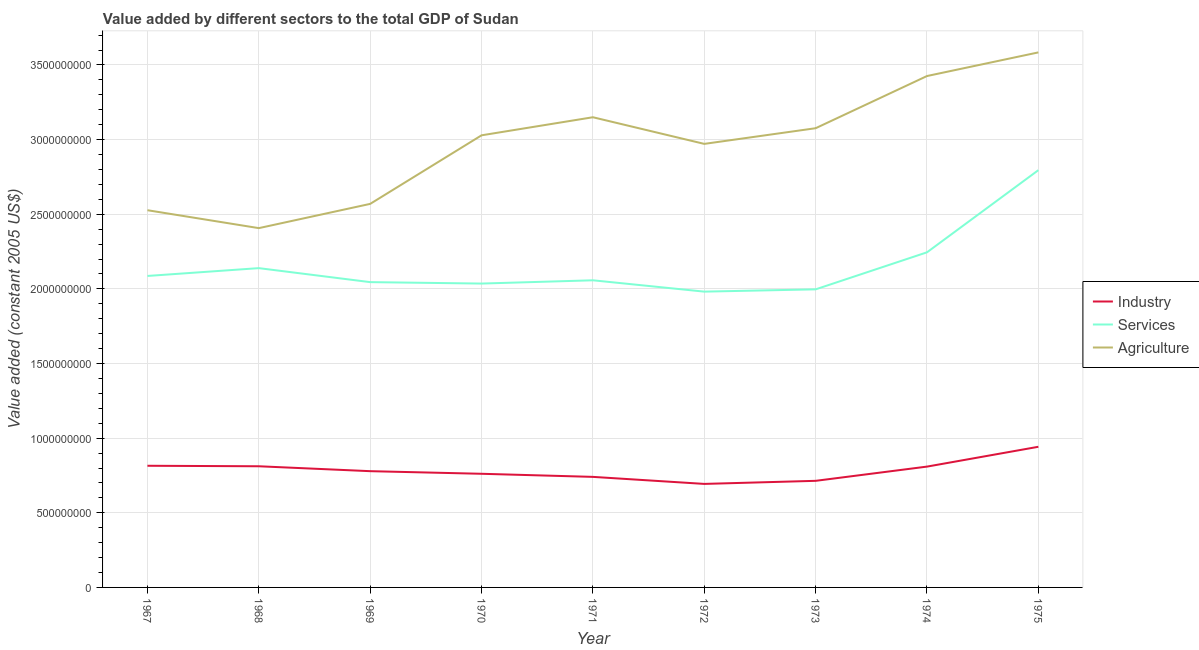How many different coloured lines are there?
Make the answer very short. 3. Does the line corresponding to value added by agricultural sector intersect with the line corresponding to value added by industrial sector?
Offer a very short reply. No. Is the number of lines equal to the number of legend labels?
Your response must be concise. Yes. What is the value added by services in 1967?
Your answer should be very brief. 2.09e+09. Across all years, what is the maximum value added by services?
Your answer should be compact. 2.80e+09. Across all years, what is the minimum value added by industrial sector?
Offer a very short reply. 6.93e+08. In which year was the value added by industrial sector maximum?
Offer a very short reply. 1975. What is the total value added by industrial sector in the graph?
Keep it short and to the point. 7.07e+09. What is the difference between the value added by industrial sector in 1972 and that in 1973?
Keep it short and to the point. -2.06e+07. What is the difference between the value added by industrial sector in 1971 and the value added by services in 1973?
Give a very brief answer. -1.26e+09. What is the average value added by services per year?
Your response must be concise. 2.15e+09. In the year 1969, what is the difference between the value added by agricultural sector and value added by industrial sector?
Provide a short and direct response. 1.79e+09. In how many years, is the value added by agricultural sector greater than 2300000000 US$?
Offer a terse response. 9. What is the ratio of the value added by industrial sector in 1970 to that in 1975?
Give a very brief answer. 0.81. Is the value added by agricultural sector in 1972 less than that in 1974?
Provide a short and direct response. Yes. What is the difference between the highest and the second highest value added by services?
Your response must be concise. 5.50e+08. What is the difference between the highest and the lowest value added by industrial sector?
Offer a very short reply. 2.49e+08. Does the value added by services monotonically increase over the years?
Offer a terse response. No. Is the value added by agricultural sector strictly greater than the value added by industrial sector over the years?
Keep it short and to the point. Yes. Is the value added by industrial sector strictly less than the value added by agricultural sector over the years?
Offer a very short reply. Yes. Does the graph contain grids?
Ensure brevity in your answer.  Yes. How many legend labels are there?
Your answer should be very brief. 3. How are the legend labels stacked?
Make the answer very short. Vertical. What is the title of the graph?
Provide a short and direct response. Value added by different sectors to the total GDP of Sudan. Does "Gaseous fuel" appear as one of the legend labels in the graph?
Make the answer very short. No. What is the label or title of the Y-axis?
Your response must be concise. Value added (constant 2005 US$). What is the Value added (constant 2005 US$) in Industry in 1967?
Offer a terse response. 8.15e+08. What is the Value added (constant 2005 US$) in Services in 1967?
Offer a very short reply. 2.09e+09. What is the Value added (constant 2005 US$) in Agriculture in 1967?
Your response must be concise. 2.53e+09. What is the Value added (constant 2005 US$) in Industry in 1968?
Provide a short and direct response. 8.12e+08. What is the Value added (constant 2005 US$) in Services in 1968?
Keep it short and to the point. 2.14e+09. What is the Value added (constant 2005 US$) in Agriculture in 1968?
Offer a very short reply. 2.41e+09. What is the Value added (constant 2005 US$) in Industry in 1969?
Offer a very short reply. 7.79e+08. What is the Value added (constant 2005 US$) in Services in 1969?
Your response must be concise. 2.05e+09. What is the Value added (constant 2005 US$) of Agriculture in 1969?
Your response must be concise. 2.57e+09. What is the Value added (constant 2005 US$) of Industry in 1970?
Offer a terse response. 7.61e+08. What is the Value added (constant 2005 US$) of Services in 1970?
Provide a short and direct response. 2.04e+09. What is the Value added (constant 2005 US$) in Agriculture in 1970?
Offer a terse response. 3.03e+09. What is the Value added (constant 2005 US$) in Industry in 1971?
Offer a very short reply. 7.41e+08. What is the Value added (constant 2005 US$) in Services in 1971?
Give a very brief answer. 2.06e+09. What is the Value added (constant 2005 US$) of Agriculture in 1971?
Your answer should be very brief. 3.15e+09. What is the Value added (constant 2005 US$) in Industry in 1972?
Your answer should be very brief. 6.93e+08. What is the Value added (constant 2005 US$) in Services in 1972?
Offer a very short reply. 1.98e+09. What is the Value added (constant 2005 US$) in Agriculture in 1972?
Your response must be concise. 2.97e+09. What is the Value added (constant 2005 US$) in Industry in 1973?
Keep it short and to the point. 7.14e+08. What is the Value added (constant 2005 US$) in Services in 1973?
Offer a very short reply. 2.00e+09. What is the Value added (constant 2005 US$) in Agriculture in 1973?
Offer a very short reply. 3.08e+09. What is the Value added (constant 2005 US$) in Industry in 1974?
Give a very brief answer. 8.09e+08. What is the Value added (constant 2005 US$) in Services in 1974?
Your answer should be very brief. 2.24e+09. What is the Value added (constant 2005 US$) of Agriculture in 1974?
Your response must be concise. 3.43e+09. What is the Value added (constant 2005 US$) in Industry in 1975?
Ensure brevity in your answer.  9.42e+08. What is the Value added (constant 2005 US$) of Services in 1975?
Keep it short and to the point. 2.80e+09. What is the Value added (constant 2005 US$) in Agriculture in 1975?
Provide a short and direct response. 3.58e+09. Across all years, what is the maximum Value added (constant 2005 US$) of Industry?
Your response must be concise. 9.42e+08. Across all years, what is the maximum Value added (constant 2005 US$) of Services?
Keep it short and to the point. 2.80e+09. Across all years, what is the maximum Value added (constant 2005 US$) in Agriculture?
Offer a terse response. 3.58e+09. Across all years, what is the minimum Value added (constant 2005 US$) in Industry?
Provide a succinct answer. 6.93e+08. Across all years, what is the minimum Value added (constant 2005 US$) in Services?
Provide a short and direct response. 1.98e+09. Across all years, what is the minimum Value added (constant 2005 US$) in Agriculture?
Make the answer very short. 2.41e+09. What is the total Value added (constant 2005 US$) of Industry in the graph?
Provide a succinct answer. 7.07e+09. What is the total Value added (constant 2005 US$) in Services in the graph?
Ensure brevity in your answer.  1.94e+1. What is the total Value added (constant 2005 US$) in Agriculture in the graph?
Offer a very short reply. 2.67e+1. What is the difference between the Value added (constant 2005 US$) of Industry in 1967 and that in 1968?
Offer a terse response. 3.33e+06. What is the difference between the Value added (constant 2005 US$) in Services in 1967 and that in 1968?
Provide a succinct answer. -5.24e+07. What is the difference between the Value added (constant 2005 US$) in Agriculture in 1967 and that in 1968?
Make the answer very short. 1.20e+08. What is the difference between the Value added (constant 2005 US$) in Industry in 1967 and that in 1969?
Your answer should be very brief. 3.62e+07. What is the difference between the Value added (constant 2005 US$) in Services in 1967 and that in 1969?
Your answer should be very brief. 4.14e+07. What is the difference between the Value added (constant 2005 US$) of Agriculture in 1967 and that in 1969?
Make the answer very short. -4.23e+07. What is the difference between the Value added (constant 2005 US$) in Industry in 1967 and that in 1970?
Your answer should be very brief. 5.36e+07. What is the difference between the Value added (constant 2005 US$) of Services in 1967 and that in 1970?
Your answer should be very brief. 5.10e+07. What is the difference between the Value added (constant 2005 US$) in Agriculture in 1967 and that in 1970?
Your answer should be very brief. -5.02e+08. What is the difference between the Value added (constant 2005 US$) of Industry in 1967 and that in 1971?
Your answer should be compact. 7.44e+07. What is the difference between the Value added (constant 2005 US$) of Services in 1967 and that in 1971?
Your answer should be very brief. 2.91e+07. What is the difference between the Value added (constant 2005 US$) of Agriculture in 1967 and that in 1971?
Your answer should be compact. -6.23e+08. What is the difference between the Value added (constant 2005 US$) in Industry in 1967 and that in 1972?
Ensure brevity in your answer.  1.22e+08. What is the difference between the Value added (constant 2005 US$) in Services in 1967 and that in 1972?
Your answer should be very brief. 1.05e+08. What is the difference between the Value added (constant 2005 US$) in Agriculture in 1967 and that in 1972?
Ensure brevity in your answer.  -4.44e+08. What is the difference between the Value added (constant 2005 US$) in Industry in 1967 and that in 1973?
Offer a very short reply. 1.01e+08. What is the difference between the Value added (constant 2005 US$) in Services in 1967 and that in 1973?
Keep it short and to the point. 8.98e+07. What is the difference between the Value added (constant 2005 US$) in Agriculture in 1967 and that in 1973?
Ensure brevity in your answer.  -5.49e+08. What is the difference between the Value added (constant 2005 US$) of Industry in 1967 and that in 1974?
Make the answer very short. 5.62e+06. What is the difference between the Value added (constant 2005 US$) of Services in 1967 and that in 1974?
Keep it short and to the point. -1.58e+08. What is the difference between the Value added (constant 2005 US$) of Agriculture in 1967 and that in 1974?
Offer a terse response. -8.99e+08. What is the difference between the Value added (constant 2005 US$) in Industry in 1967 and that in 1975?
Your answer should be very brief. -1.27e+08. What is the difference between the Value added (constant 2005 US$) in Services in 1967 and that in 1975?
Provide a short and direct response. -7.09e+08. What is the difference between the Value added (constant 2005 US$) of Agriculture in 1967 and that in 1975?
Your response must be concise. -1.06e+09. What is the difference between the Value added (constant 2005 US$) in Industry in 1968 and that in 1969?
Offer a very short reply. 3.29e+07. What is the difference between the Value added (constant 2005 US$) in Services in 1968 and that in 1969?
Offer a very short reply. 9.37e+07. What is the difference between the Value added (constant 2005 US$) in Agriculture in 1968 and that in 1969?
Give a very brief answer. -1.62e+08. What is the difference between the Value added (constant 2005 US$) in Industry in 1968 and that in 1970?
Ensure brevity in your answer.  5.03e+07. What is the difference between the Value added (constant 2005 US$) of Services in 1968 and that in 1970?
Offer a very short reply. 1.03e+08. What is the difference between the Value added (constant 2005 US$) of Agriculture in 1968 and that in 1970?
Your response must be concise. -6.22e+08. What is the difference between the Value added (constant 2005 US$) in Industry in 1968 and that in 1971?
Your answer should be very brief. 7.11e+07. What is the difference between the Value added (constant 2005 US$) in Services in 1968 and that in 1971?
Provide a succinct answer. 8.15e+07. What is the difference between the Value added (constant 2005 US$) in Agriculture in 1968 and that in 1971?
Ensure brevity in your answer.  -7.43e+08. What is the difference between the Value added (constant 2005 US$) of Industry in 1968 and that in 1972?
Give a very brief answer. 1.18e+08. What is the difference between the Value added (constant 2005 US$) in Services in 1968 and that in 1972?
Provide a short and direct response. 1.57e+08. What is the difference between the Value added (constant 2005 US$) in Agriculture in 1968 and that in 1972?
Make the answer very short. -5.64e+08. What is the difference between the Value added (constant 2005 US$) in Industry in 1968 and that in 1973?
Provide a short and direct response. 9.76e+07. What is the difference between the Value added (constant 2005 US$) of Services in 1968 and that in 1973?
Your response must be concise. 1.42e+08. What is the difference between the Value added (constant 2005 US$) in Agriculture in 1968 and that in 1973?
Provide a succinct answer. -6.69e+08. What is the difference between the Value added (constant 2005 US$) of Industry in 1968 and that in 1974?
Provide a short and direct response. 2.29e+06. What is the difference between the Value added (constant 2005 US$) of Services in 1968 and that in 1974?
Offer a very short reply. -1.06e+08. What is the difference between the Value added (constant 2005 US$) of Agriculture in 1968 and that in 1974?
Make the answer very short. -1.02e+09. What is the difference between the Value added (constant 2005 US$) in Industry in 1968 and that in 1975?
Keep it short and to the point. -1.31e+08. What is the difference between the Value added (constant 2005 US$) in Services in 1968 and that in 1975?
Your response must be concise. -6.56e+08. What is the difference between the Value added (constant 2005 US$) in Agriculture in 1968 and that in 1975?
Your response must be concise. -1.18e+09. What is the difference between the Value added (constant 2005 US$) in Industry in 1969 and that in 1970?
Your answer should be very brief. 1.74e+07. What is the difference between the Value added (constant 2005 US$) of Services in 1969 and that in 1970?
Your response must be concise. 9.57e+06. What is the difference between the Value added (constant 2005 US$) of Agriculture in 1969 and that in 1970?
Your answer should be compact. -4.59e+08. What is the difference between the Value added (constant 2005 US$) of Industry in 1969 and that in 1971?
Your answer should be compact. 3.82e+07. What is the difference between the Value added (constant 2005 US$) of Services in 1969 and that in 1971?
Offer a very short reply. -1.23e+07. What is the difference between the Value added (constant 2005 US$) in Agriculture in 1969 and that in 1971?
Keep it short and to the point. -5.80e+08. What is the difference between the Value added (constant 2005 US$) of Industry in 1969 and that in 1972?
Offer a terse response. 8.53e+07. What is the difference between the Value added (constant 2005 US$) in Services in 1969 and that in 1972?
Your answer should be very brief. 6.36e+07. What is the difference between the Value added (constant 2005 US$) of Agriculture in 1969 and that in 1972?
Keep it short and to the point. -4.02e+08. What is the difference between the Value added (constant 2005 US$) of Industry in 1969 and that in 1973?
Make the answer very short. 6.47e+07. What is the difference between the Value added (constant 2005 US$) in Services in 1969 and that in 1973?
Give a very brief answer. 4.84e+07. What is the difference between the Value added (constant 2005 US$) in Agriculture in 1969 and that in 1973?
Make the answer very short. -5.07e+08. What is the difference between the Value added (constant 2005 US$) in Industry in 1969 and that in 1974?
Your response must be concise. -3.06e+07. What is the difference between the Value added (constant 2005 US$) in Services in 1969 and that in 1974?
Offer a very short reply. -2.00e+08. What is the difference between the Value added (constant 2005 US$) of Agriculture in 1969 and that in 1974?
Make the answer very short. -8.56e+08. What is the difference between the Value added (constant 2005 US$) in Industry in 1969 and that in 1975?
Ensure brevity in your answer.  -1.63e+08. What is the difference between the Value added (constant 2005 US$) of Services in 1969 and that in 1975?
Your answer should be compact. -7.50e+08. What is the difference between the Value added (constant 2005 US$) of Agriculture in 1969 and that in 1975?
Keep it short and to the point. -1.01e+09. What is the difference between the Value added (constant 2005 US$) of Industry in 1970 and that in 1971?
Keep it short and to the point. 2.08e+07. What is the difference between the Value added (constant 2005 US$) of Services in 1970 and that in 1971?
Your answer should be very brief. -2.19e+07. What is the difference between the Value added (constant 2005 US$) of Agriculture in 1970 and that in 1971?
Offer a very short reply. -1.21e+08. What is the difference between the Value added (constant 2005 US$) in Industry in 1970 and that in 1972?
Provide a succinct answer. 6.79e+07. What is the difference between the Value added (constant 2005 US$) in Services in 1970 and that in 1972?
Make the answer very short. 5.41e+07. What is the difference between the Value added (constant 2005 US$) in Agriculture in 1970 and that in 1972?
Offer a terse response. 5.74e+07. What is the difference between the Value added (constant 2005 US$) of Industry in 1970 and that in 1973?
Ensure brevity in your answer.  4.73e+07. What is the difference between the Value added (constant 2005 US$) in Services in 1970 and that in 1973?
Provide a short and direct response. 3.88e+07. What is the difference between the Value added (constant 2005 US$) in Agriculture in 1970 and that in 1973?
Keep it short and to the point. -4.75e+07. What is the difference between the Value added (constant 2005 US$) in Industry in 1970 and that in 1974?
Offer a terse response. -4.80e+07. What is the difference between the Value added (constant 2005 US$) in Services in 1970 and that in 1974?
Your answer should be very brief. -2.09e+08. What is the difference between the Value added (constant 2005 US$) in Agriculture in 1970 and that in 1974?
Your response must be concise. -3.97e+08. What is the difference between the Value added (constant 2005 US$) in Industry in 1970 and that in 1975?
Provide a succinct answer. -1.81e+08. What is the difference between the Value added (constant 2005 US$) of Services in 1970 and that in 1975?
Your answer should be compact. -7.60e+08. What is the difference between the Value added (constant 2005 US$) of Agriculture in 1970 and that in 1975?
Your response must be concise. -5.55e+08. What is the difference between the Value added (constant 2005 US$) in Industry in 1971 and that in 1972?
Ensure brevity in your answer.  4.71e+07. What is the difference between the Value added (constant 2005 US$) of Services in 1971 and that in 1972?
Provide a succinct answer. 7.59e+07. What is the difference between the Value added (constant 2005 US$) of Agriculture in 1971 and that in 1972?
Your response must be concise. 1.78e+08. What is the difference between the Value added (constant 2005 US$) in Industry in 1971 and that in 1973?
Your answer should be very brief. 2.65e+07. What is the difference between the Value added (constant 2005 US$) of Services in 1971 and that in 1973?
Offer a very short reply. 6.07e+07. What is the difference between the Value added (constant 2005 US$) of Agriculture in 1971 and that in 1973?
Your answer should be very brief. 7.35e+07. What is the difference between the Value added (constant 2005 US$) of Industry in 1971 and that in 1974?
Your answer should be very brief. -6.88e+07. What is the difference between the Value added (constant 2005 US$) of Services in 1971 and that in 1974?
Offer a very short reply. -1.87e+08. What is the difference between the Value added (constant 2005 US$) of Agriculture in 1971 and that in 1974?
Your answer should be very brief. -2.76e+08. What is the difference between the Value added (constant 2005 US$) in Industry in 1971 and that in 1975?
Provide a succinct answer. -2.02e+08. What is the difference between the Value added (constant 2005 US$) of Services in 1971 and that in 1975?
Your answer should be very brief. -7.38e+08. What is the difference between the Value added (constant 2005 US$) in Agriculture in 1971 and that in 1975?
Ensure brevity in your answer.  -4.34e+08. What is the difference between the Value added (constant 2005 US$) of Industry in 1972 and that in 1973?
Offer a terse response. -2.06e+07. What is the difference between the Value added (constant 2005 US$) of Services in 1972 and that in 1973?
Your answer should be compact. -1.53e+07. What is the difference between the Value added (constant 2005 US$) of Agriculture in 1972 and that in 1973?
Provide a succinct answer. -1.05e+08. What is the difference between the Value added (constant 2005 US$) of Industry in 1972 and that in 1974?
Make the answer very short. -1.16e+08. What is the difference between the Value added (constant 2005 US$) of Services in 1972 and that in 1974?
Provide a succinct answer. -2.63e+08. What is the difference between the Value added (constant 2005 US$) of Agriculture in 1972 and that in 1974?
Provide a short and direct response. -4.55e+08. What is the difference between the Value added (constant 2005 US$) in Industry in 1972 and that in 1975?
Make the answer very short. -2.49e+08. What is the difference between the Value added (constant 2005 US$) in Services in 1972 and that in 1975?
Provide a short and direct response. -8.14e+08. What is the difference between the Value added (constant 2005 US$) in Agriculture in 1972 and that in 1975?
Your answer should be very brief. -6.13e+08. What is the difference between the Value added (constant 2005 US$) in Industry in 1973 and that in 1974?
Make the answer very short. -9.53e+07. What is the difference between the Value added (constant 2005 US$) of Services in 1973 and that in 1974?
Ensure brevity in your answer.  -2.48e+08. What is the difference between the Value added (constant 2005 US$) in Agriculture in 1973 and that in 1974?
Your response must be concise. -3.50e+08. What is the difference between the Value added (constant 2005 US$) in Industry in 1973 and that in 1975?
Your response must be concise. -2.28e+08. What is the difference between the Value added (constant 2005 US$) of Services in 1973 and that in 1975?
Provide a short and direct response. -7.98e+08. What is the difference between the Value added (constant 2005 US$) of Agriculture in 1973 and that in 1975?
Keep it short and to the point. -5.08e+08. What is the difference between the Value added (constant 2005 US$) of Industry in 1974 and that in 1975?
Make the answer very short. -1.33e+08. What is the difference between the Value added (constant 2005 US$) in Services in 1974 and that in 1975?
Give a very brief answer. -5.50e+08. What is the difference between the Value added (constant 2005 US$) of Agriculture in 1974 and that in 1975?
Your answer should be compact. -1.58e+08. What is the difference between the Value added (constant 2005 US$) of Industry in 1967 and the Value added (constant 2005 US$) of Services in 1968?
Provide a short and direct response. -1.32e+09. What is the difference between the Value added (constant 2005 US$) in Industry in 1967 and the Value added (constant 2005 US$) in Agriculture in 1968?
Provide a short and direct response. -1.59e+09. What is the difference between the Value added (constant 2005 US$) in Services in 1967 and the Value added (constant 2005 US$) in Agriculture in 1968?
Offer a very short reply. -3.20e+08. What is the difference between the Value added (constant 2005 US$) of Industry in 1967 and the Value added (constant 2005 US$) of Services in 1969?
Your answer should be compact. -1.23e+09. What is the difference between the Value added (constant 2005 US$) of Industry in 1967 and the Value added (constant 2005 US$) of Agriculture in 1969?
Your answer should be compact. -1.75e+09. What is the difference between the Value added (constant 2005 US$) in Services in 1967 and the Value added (constant 2005 US$) in Agriculture in 1969?
Your answer should be very brief. -4.83e+08. What is the difference between the Value added (constant 2005 US$) in Industry in 1967 and the Value added (constant 2005 US$) in Services in 1970?
Keep it short and to the point. -1.22e+09. What is the difference between the Value added (constant 2005 US$) of Industry in 1967 and the Value added (constant 2005 US$) of Agriculture in 1970?
Make the answer very short. -2.21e+09. What is the difference between the Value added (constant 2005 US$) in Services in 1967 and the Value added (constant 2005 US$) in Agriculture in 1970?
Offer a very short reply. -9.42e+08. What is the difference between the Value added (constant 2005 US$) of Industry in 1967 and the Value added (constant 2005 US$) of Services in 1971?
Your answer should be compact. -1.24e+09. What is the difference between the Value added (constant 2005 US$) of Industry in 1967 and the Value added (constant 2005 US$) of Agriculture in 1971?
Your answer should be compact. -2.33e+09. What is the difference between the Value added (constant 2005 US$) of Services in 1967 and the Value added (constant 2005 US$) of Agriculture in 1971?
Your answer should be compact. -1.06e+09. What is the difference between the Value added (constant 2005 US$) in Industry in 1967 and the Value added (constant 2005 US$) in Services in 1972?
Provide a short and direct response. -1.17e+09. What is the difference between the Value added (constant 2005 US$) of Industry in 1967 and the Value added (constant 2005 US$) of Agriculture in 1972?
Ensure brevity in your answer.  -2.16e+09. What is the difference between the Value added (constant 2005 US$) in Services in 1967 and the Value added (constant 2005 US$) in Agriculture in 1972?
Ensure brevity in your answer.  -8.85e+08. What is the difference between the Value added (constant 2005 US$) of Industry in 1967 and the Value added (constant 2005 US$) of Services in 1973?
Offer a very short reply. -1.18e+09. What is the difference between the Value added (constant 2005 US$) in Industry in 1967 and the Value added (constant 2005 US$) in Agriculture in 1973?
Make the answer very short. -2.26e+09. What is the difference between the Value added (constant 2005 US$) in Services in 1967 and the Value added (constant 2005 US$) in Agriculture in 1973?
Provide a succinct answer. -9.90e+08. What is the difference between the Value added (constant 2005 US$) in Industry in 1967 and the Value added (constant 2005 US$) in Services in 1974?
Your answer should be compact. -1.43e+09. What is the difference between the Value added (constant 2005 US$) of Industry in 1967 and the Value added (constant 2005 US$) of Agriculture in 1974?
Ensure brevity in your answer.  -2.61e+09. What is the difference between the Value added (constant 2005 US$) of Services in 1967 and the Value added (constant 2005 US$) of Agriculture in 1974?
Offer a terse response. -1.34e+09. What is the difference between the Value added (constant 2005 US$) of Industry in 1967 and the Value added (constant 2005 US$) of Services in 1975?
Provide a short and direct response. -1.98e+09. What is the difference between the Value added (constant 2005 US$) in Industry in 1967 and the Value added (constant 2005 US$) in Agriculture in 1975?
Ensure brevity in your answer.  -2.77e+09. What is the difference between the Value added (constant 2005 US$) in Services in 1967 and the Value added (constant 2005 US$) in Agriculture in 1975?
Provide a short and direct response. -1.50e+09. What is the difference between the Value added (constant 2005 US$) of Industry in 1968 and the Value added (constant 2005 US$) of Services in 1969?
Offer a very short reply. -1.23e+09. What is the difference between the Value added (constant 2005 US$) in Industry in 1968 and the Value added (constant 2005 US$) in Agriculture in 1969?
Offer a very short reply. -1.76e+09. What is the difference between the Value added (constant 2005 US$) in Services in 1968 and the Value added (constant 2005 US$) in Agriculture in 1969?
Offer a terse response. -4.30e+08. What is the difference between the Value added (constant 2005 US$) of Industry in 1968 and the Value added (constant 2005 US$) of Services in 1970?
Provide a succinct answer. -1.22e+09. What is the difference between the Value added (constant 2005 US$) of Industry in 1968 and the Value added (constant 2005 US$) of Agriculture in 1970?
Give a very brief answer. -2.22e+09. What is the difference between the Value added (constant 2005 US$) in Services in 1968 and the Value added (constant 2005 US$) in Agriculture in 1970?
Make the answer very short. -8.90e+08. What is the difference between the Value added (constant 2005 US$) in Industry in 1968 and the Value added (constant 2005 US$) in Services in 1971?
Ensure brevity in your answer.  -1.25e+09. What is the difference between the Value added (constant 2005 US$) of Industry in 1968 and the Value added (constant 2005 US$) of Agriculture in 1971?
Offer a terse response. -2.34e+09. What is the difference between the Value added (constant 2005 US$) in Services in 1968 and the Value added (constant 2005 US$) in Agriculture in 1971?
Keep it short and to the point. -1.01e+09. What is the difference between the Value added (constant 2005 US$) in Industry in 1968 and the Value added (constant 2005 US$) in Services in 1972?
Your answer should be compact. -1.17e+09. What is the difference between the Value added (constant 2005 US$) of Industry in 1968 and the Value added (constant 2005 US$) of Agriculture in 1972?
Offer a terse response. -2.16e+09. What is the difference between the Value added (constant 2005 US$) in Services in 1968 and the Value added (constant 2005 US$) in Agriculture in 1972?
Make the answer very short. -8.32e+08. What is the difference between the Value added (constant 2005 US$) in Industry in 1968 and the Value added (constant 2005 US$) in Services in 1973?
Your answer should be compact. -1.19e+09. What is the difference between the Value added (constant 2005 US$) of Industry in 1968 and the Value added (constant 2005 US$) of Agriculture in 1973?
Your response must be concise. -2.26e+09. What is the difference between the Value added (constant 2005 US$) of Services in 1968 and the Value added (constant 2005 US$) of Agriculture in 1973?
Provide a succinct answer. -9.37e+08. What is the difference between the Value added (constant 2005 US$) in Industry in 1968 and the Value added (constant 2005 US$) in Services in 1974?
Offer a terse response. -1.43e+09. What is the difference between the Value added (constant 2005 US$) of Industry in 1968 and the Value added (constant 2005 US$) of Agriculture in 1974?
Offer a terse response. -2.61e+09. What is the difference between the Value added (constant 2005 US$) of Services in 1968 and the Value added (constant 2005 US$) of Agriculture in 1974?
Keep it short and to the point. -1.29e+09. What is the difference between the Value added (constant 2005 US$) in Industry in 1968 and the Value added (constant 2005 US$) in Services in 1975?
Provide a short and direct response. -1.98e+09. What is the difference between the Value added (constant 2005 US$) in Industry in 1968 and the Value added (constant 2005 US$) in Agriculture in 1975?
Your response must be concise. -2.77e+09. What is the difference between the Value added (constant 2005 US$) in Services in 1968 and the Value added (constant 2005 US$) in Agriculture in 1975?
Provide a short and direct response. -1.45e+09. What is the difference between the Value added (constant 2005 US$) of Industry in 1969 and the Value added (constant 2005 US$) of Services in 1970?
Give a very brief answer. -1.26e+09. What is the difference between the Value added (constant 2005 US$) of Industry in 1969 and the Value added (constant 2005 US$) of Agriculture in 1970?
Your answer should be compact. -2.25e+09. What is the difference between the Value added (constant 2005 US$) of Services in 1969 and the Value added (constant 2005 US$) of Agriculture in 1970?
Give a very brief answer. -9.83e+08. What is the difference between the Value added (constant 2005 US$) in Industry in 1969 and the Value added (constant 2005 US$) in Services in 1971?
Ensure brevity in your answer.  -1.28e+09. What is the difference between the Value added (constant 2005 US$) of Industry in 1969 and the Value added (constant 2005 US$) of Agriculture in 1971?
Offer a terse response. -2.37e+09. What is the difference between the Value added (constant 2005 US$) of Services in 1969 and the Value added (constant 2005 US$) of Agriculture in 1971?
Make the answer very short. -1.10e+09. What is the difference between the Value added (constant 2005 US$) of Industry in 1969 and the Value added (constant 2005 US$) of Services in 1972?
Provide a short and direct response. -1.20e+09. What is the difference between the Value added (constant 2005 US$) in Industry in 1969 and the Value added (constant 2005 US$) in Agriculture in 1972?
Provide a short and direct response. -2.19e+09. What is the difference between the Value added (constant 2005 US$) in Services in 1969 and the Value added (constant 2005 US$) in Agriculture in 1972?
Make the answer very short. -9.26e+08. What is the difference between the Value added (constant 2005 US$) of Industry in 1969 and the Value added (constant 2005 US$) of Services in 1973?
Ensure brevity in your answer.  -1.22e+09. What is the difference between the Value added (constant 2005 US$) of Industry in 1969 and the Value added (constant 2005 US$) of Agriculture in 1973?
Your response must be concise. -2.30e+09. What is the difference between the Value added (constant 2005 US$) of Services in 1969 and the Value added (constant 2005 US$) of Agriculture in 1973?
Provide a short and direct response. -1.03e+09. What is the difference between the Value added (constant 2005 US$) of Industry in 1969 and the Value added (constant 2005 US$) of Services in 1974?
Offer a very short reply. -1.47e+09. What is the difference between the Value added (constant 2005 US$) of Industry in 1969 and the Value added (constant 2005 US$) of Agriculture in 1974?
Make the answer very short. -2.65e+09. What is the difference between the Value added (constant 2005 US$) of Services in 1969 and the Value added (constant 2005 US$) of Agriculture in 1974?
Give a very brief answer. -1.38e+09. What is the difference between the Value added (constant 2005 US$) in Industry in 1969 and the Value added (constant 2005 US$) in Services in 1975?
Offer a very short reply. -2.02e+09. What is the difference between the Value added (constant 2005 US$) in Industry in 1969 and the Value added (constant 2005 US$) in Agriculture in 1975?
Provide a succinct answer. -2.81e+09. What is the difference between the Value added (constant 2005 US$) in Services in 1969 and the Value added (constant 2005 US$) in Agriculture in 1975?
Make the answer very short. -1.54e+09. What is the difference between the Value added (constant 2005 US$) in Industry in 1970 and the Value added (constant 2005 US$) in Services in 1971?
Your answer should be compact. -1.30e+09. What is the difference between the Value added (constant 2005 US$) of Industry in 1970 and the Value added (constant 2005 US$) of Agriculture in 1971?
Offer a very short reply. -2.39e+09. What is the difference between the Value added (constant 2005 US$) in Services in 1970 and the Value added (constant 2005 US$) in Agriculture in 1971?
Your response must be concise. -1.11e+09. What is the difference between the Value added (constant 2005 US$) in Industry in 1970 and the Value added (constant 2005 US$) in Services in 1972?
Your answer should be very brief. -1.22e+09. What is the difference between the Value added (constant 2005 US$) of Industry in 1970 and the Value added (constant 2005 US$) of Agriculture in 1972?
Your answer should be very brief. -2.21e+09. What is the difference between the Value added (constant 2005 US$) in Services in 1970 and the Value added (constant 2005 US$) in Agriculture in 1972?
Keep it short and to the point. -9.36e+08. What is the difference between the Value added (constant 2005 US$) in Industry in 1970 and the Value added (constant 2005 US$) in Services in 1973?
Your answer should be compact. -1.24e+09. What is the difference between the Value added (constant 2005 US$) of Industry in 1970 and the Value added (constant 2005 US$) of Agriculture in 1973?
Your answer should be very brief. -2.31e+09. What is the difference between the Value added (constant 2005 US$) in Services in 1970 and the Value added (constant 2005 US$) in Agriculture in 1973?
Your answer should be compact. -1.04e+09. What is the difference between the Value added (constant 2005 US$) in Industry in 1970 and the Value added (constant 2005 US$) in Services in 1974?
Keep it short and to the point. -1.48e+09. What is the difference between the Value added (constant 2005 US$) of Industry in 1970 and the Value added (constant 2005 US$) of Agriculture in 1974?
Offer a very short reply. -2.66e+09. What is the difference between the Value added (constant 2005 US$) of Services in 1970 and the Value added (constant 2005 US$) of Agriculture in 1974?
Ensure brevity in your answer.  -1.39e+09. What is the difference between the Value added (constant 2005 US$) in Industry in 1970 and the Value added (constant 2005 US$) in Services in 1975?
Ensure brevity in your answer.  -2.03e+09. What is the difference between the Value added (constant 2005 US$) of Industry in 1970 and the Value added (constant 2005 US$) of Agriculture in 1975?
Keep it short and to the point. -2.82e+09. What is the difference between the Value added (constant 2005 US$) in Services in 1970 and the Value added (constant 2005 US$) in Agriculture in 1975?
Provide a succinct answer. -1.55e+09. What is the difference between the Value added (constant 2005 US$) of Industry in 1971 and the Value added (constant 2005 US$) of Services in 1972?
Offer a very short reply. -1.24e+09. What is the difference between the Value added (constant 2005 US$) in Industry in 1971 and the Value added (constant 2005 US$) in Agriculture in 1972?
Keep it short and to the point. -2.23e+09. What is the difference between the Value added (constant 2005 US$) in Services in 1971 and the Value added (constant 2005 US$) in Agriculture in 1972?
Provide a succinct answer. -9.14e+08. What is the difference between the Value added (constant 2005 US$) of Industry in 1971 and the Value added (constant 2005 US$) of Services in 1973?
Ensure brevity in your answer.  -1.26e+09. What is the difference between the Value added (constant 2005 US$) of Industry in 1971 and the Value added (constant 2005 US$) of Agriculture in 1973?
Keep it short and to the point. -2.34e+09. What is the difference between the Value added (constant 2005 US$) of Services in 1971 and the Value added (constant 2005 US$) of Agriculture in 1973?
Offer a very short reply. -1.02e+09. What is the difference between the Value added (constant 2005 US$) in Industry in 1971 and the Value added (constant 2005 US$) in Services in 1974?
Offer a very short reply. -1.50e+09. What is the difference between the Value added (constant 2005 US$) of Industry in 1971 and the Value added (constant 2005 US$) of Agriculture in 1974?
Ensure brevity in your answer.  -2.69e+09. What is the difference between the Value added (constant 2005 US$) of Services in 1971 and the Value added (constant 2005 US$) of Agriculture in 1974?
Provide a succinct answer. -1.37e+09. What is the difference between the Value added (constant 2005 US$) of Industry in 1971 and the Value added (constant 2005 US$) of Services in 1975?
Make the answer very short. -2.05e+09. What is the difference between the Value added (constant 2005 US$) of Industry in 1971 and the Value added (constant 2005 US$) of Agriculture in 1975?
Provide a short and direct response. -2.84e+09. What is the difference between the Value added (constant 2005 US$) in Services in 1971 and the Value added (constant 2005 US$) in Agriculture in 1975?
Offer a very short reply. -1.53e+09. What is the difference between the Value added (constant 2005 US$) of Industry in 1972 and the Value added (constant 2005 US$) of Services in 1973?
Make the answer very short. -1.30e+09. What is the difference between the Value added (constant 2005 US$) in Industry in 1972 and the Value added (constant 2005 US$) in Agriculture in 1973?
Keep it short and to the point. -2.38e+09. What is the difference between the Value added (constant 2005 US$) of Services in 1972 and the Value added (constant 2005 US$) of Agriculture in 1973?
Provide a short and direct response. -1.09e+09. What is the difference between the Value added (constant 2005 US$) in Industry in 1972 and the Value added (constant 2005 US$) in Services in 1974?
Your answer should be compact. -1.55e+09. What is the difference between the Value added (constant 2005 US$) of Industry in 1972 and the Value added (constant 2005 US$) of Agriculture in 1974?
Provide a short and direct response. -2.73e+09. What is the difference between the Value added (constant 2005 US$) in Services in 1972 and the Value added (constant 2005 US$) in Agriculture in 1974?
Your response must be concise. -1.44e+09. What is the difference between the Value added (constant 2005 US$) in Industry in 1972 and the Value added (constant 2005 US$) in Services in 1975?
Provide a short and direct response. -2.10e+09. What is the difference between the Value added (constant 2005 US$) in Industry in 1972 and the Value added (constant 2005 US$) in Agriculture in 1975?
Ensure brevity in your answer.  -2.89e+09. What is the difference between the Value added (constant 2005 US$) of Services in 1972 and the Value added (constant 2005 US$) of Agriculture in 1975?
Give a very brief answer. -1.60e+09. What is the difference between the Value added (constant 2005 US$) in Industry in 1973 and the Value added (constant 2005 US$) in Services in 1974?
Provide a short and direct response. -1.53e+09. What is the difference between the Value added (constant 2005 US$) in Industry in 1973 and the Value added (constant 2005 US$) in Agriculture in 1974?
Your answer should be very brief. -2.71e+09. What is the difference between the Value added (constant 2005 US$) of Services in 1973 and the Value added (constant 2005 US$) of Agriculture in 1974?
Keep it short and to the point. -1.43e+09. What is the difference between the Value added (constant 2005 US$) in Industry in 1973 and the Value added (constant 2005 US$) in Services in 1975?
Ensure brevity in your answer.  -2.08e+09. What is the difference between the Value added (constant 2005 US$) in Industry in 1973 and the Value added (constant 2005 US$) in Agriculture in 1975?
Your answer should be very brief. -2.87e+09. What is the difference between the Value added (constant 2005 US$) of Services in 1973 and the Value added (constant 2005 US$) of Agriculture in 1975?
Offer a very short reply. -1.59e+09. What is the difference between the Value added (constant 2005 US$) of Industry in 1974 and the Value added (constant 2005 US$) of Services in 1975?
Offer a very short reply. -1.99e+09. What is the difference between the Value added (constant 2005 US$) of Industry in 1974 and the Value added (constant 2005 US$) of Agriculture in 1975?
Your response must be concise. -2.77e+09. What is the difference between the Value added (constant 2005 US$) in Services in 1974 and the Value added (constant 2005 US$) in Agriculture in 1975?
Your answer should be compact. -1.34e+09. What is the average Value added (constant 2005 US$) of Industry per year?
Provide a succinct answer. 7.85e+08. What is the average Value added (constant 2005 US$) in Services per year?
Make the answer very short. 2.15e+09. What is the average Value added (constant 2005 US$) of Agriculture per year?
Ensure brevity in your answer.  2.97e+09. In the year 1967, what is the difference between the Value added (constant 2005 US$) in Industry and Value added (constant 2005 US$) in Services?
Your response must be concise. -1.27e+09. In the year 1967, what is the difference between the Value added (constant 2005 US$) of Industry and Value added (constant 2005 US$) of Agriculture?
Ensure brevity in your answer.  -1.71e+09. In the year 1967, what is the difference between the Value added (constant 2005 US$) of Services and Value added (constant 2005 US$) of Agriculture?
Give a very brief answer. -4.40e+08. In the year 1968, what is the difference between the Value added (constant 2005 US$) in Industry and Value added (constant 2005 US$) in Services?
Offer a terse response. -1.33e+09. In the year 1968, what is the difference between the Value added (constant 2005 US$) in Industry and Value added (constant 2005 US$) in Agriculture?
Your response must be concise. -1.60e+09. In the year 1968, what is the difference between the Value added (constant 2005 US$) of Services and Value added (constant 2005 US$) of Agriculture?
Your answer should be very brief. -2.68e+08. In the year 1969, what is the difference between the Value added (constant 2005 US$) of Industry and Value added (constant 2005 US$) of Services?
Provide a short and direct response. -1.27e+09. In the year 1969, what is the difference between the Value added (constant 2005 US$) of Industry and Value added (constant 2005 US$) of Agriculture?
Ensure brevity in your answer.  -1.79e+09. In the year 1969, what is the difference between the Value added (constant 2005 US$) in Services and Value added (constant 2005 US$) in Agriculture?
Give a very brief answer. -5.24e+08. In the year 1970, what is the difference between the Value added (constant 2005 US$) in Industry and Value added (constant 2005 US$) in Services?
Provide a short and direct response. -1.27e+09. In the year 1970, what is the difference between the Value added (constant 2005 US$) of Industry and Value added (constant 2005 US$) of Agriculture?
Provide a succinct answer. -2.27e+09. In the year 1970, what is the difference between the Value added (constant 2005 US$) in Services and Value added (constant 2005 US$) in Agriculture?
Give a very brief answer. -9.93e+08. In the year 1971, what is the difference between the Value added (constant 2005 US$) in Industry and Value added (constant 2005 US$) in Services?
Make the answer very short. -1.32e+09. In the year 1971, what is the difference between the Value added (constant 2005 US$) of Industry and Value added (constant 2005 US$) of Agriculture?
Offer a terse response. -2.41e+09. In the year 1971, what is the difference between the Value added (constant 2005 US$) in Services and Value added (constant 2005 US$) in Agriculture?
Provide a short and direct response. -1.09e+09. In the year 1972, what is the difference between the Value added (constant 2005 US$) in Industry and Value added (constant 2005 US$) in Services?
Your answer should be compact. -1.29e+09. In the year 1972, what is the difference between the Value added (constant 2005 US$) of Industry and Value added (constant 2005 US$) of Agriculture?
Make the answer very short. -2.28e+09. In the year 1972, what is the difference between the Value added (constant 2005 US$) in Services and Value added (constant 2005 US$) in Agriculture?
Offer a very short reply. -9.90e+08. In the year 1973, what is the difference between the Value added (constant 2005 US$) of Industry and Value added (constant 2005 US$) of Services?
Your response must be concise. -1.28e+09. In the year 1973, what is the difference between the Value added (constant 2005 US$) in Industry and Value added (constant 2005 US$) in Agriculture?
Make the answer very short. -2.36e+09. In the year 1973, what is the difference between the Value added (constant 2005 US$) of Services and Value added (constant 2005 US$) of Agriculture?
Your answer should be compact. -1.08e+09. In the year 1974, what is the difference between the Value added (constant 2005 US$) of Industry and Value added (constant 2005 US$) of Services?
Offer a terse response. -1.44e+09. In the year 1974, what is the difference between the Value added (constant 2005 US$) in Industry and Value added (constant 2005 US$) in Agriculture?
Provide a short and direct response. -2.62e+09. In the year 1974, what is the difference between the Value added (constant 2005 US$) of Services and Value added (constant 2005 US$) of Agriculture?
Provide a succinct answer. -1.18e+09. In the year 1975, what is the difference between the Value added (constant 2005 US$) in Industry and Value added (constant 2005 US$) in Services?
Your response must be concise. -1.85e+09. In the year 1975, what is the difference between the Value added (constant 2005 US$) in Industry and Value added (constant 2005 US$) in Agriculture?
Make the answer very short. -2.64e+09. In the year 1975, what is the difference between the Value added (constant 2005 US$) in Services and Value added (constant 2005 US$) in Agriculture?
Offer a very short reply. -7.89e+08. What is the ratio of the Value added (constant 2005 US$) of Industry in 1967 to that in 1968?
Provide a succinct answer. 1. What is the ratio of the Value added (constant 2005 US$) of Services in 1967 to that in 1968?
Make the answer very short. 0.98. What is the ratio of the Value added (constant 2005 US$) of Agriculture in 1967 to that in 1968?
Offer a very short reply. 1.05. What is the ratio of the Value added (constant 2005 US$) of Industry in 1967 to that in 1969?
Offer a terse response. 1.05. What is the ratio of the Value added (constant 2005 US$) in Services in 1967 to that in 1969?
Your answer should be compact. 1.02. What is the ratio of the Value added (constant 2005 US$) of Agriculture in 1967 to that in 1969?
Your answer should be compact. 0.98. What is the ratio of the Value added (constant 2005 US$) in Industry in 1967 to that in 1970?
Make the answer very short. 1.07. What is the ratio of the Value added (constant 2005 US$) in Services in 1967 to that in 1970?
Ensure brevity in your answer.  1.02. What is the ratio of the Value added (constant 2005 US$) in Agriculture in 1967 to that in 1970?
Ensure brevity in your answer.  0.83. What is the ratio of the Value added (constant 2005 US$) of Industry in 1967 to that in 1971?
Ensure brevity in your answer.  1.1. What is the ratio of the Value added (constant 2005 US$) of Services in 1967 to that in 1971?
Provide a short and direct response. 1.01. What is the ratio of the Value added (constant 2005 US$) of Agriculture in 1967 to that in 1971?
Make the answer very short. 0.8. What is the ratio of the Value added (constant 2005 US$) in Industry in 1967 to that in 1972?
Provide a succinct answer. 1.18. What is the ratio of the Value added (constant 2005 US$) of Services in 1967 to that in 1972?
Offer a very short reply. 1.05. What is the ratio of the Value added (constant 2005 US$) of Agriculture in 1967 to that in 1972?
Your answer should be compact. 0.85. What is the ratio of the Value added (constant 2005 US$) of Industry in 1967 to that in 1973?
Keep it short and to the point. 1.14. What is the ratio of the Value added (constant 2005 US$) of Services in 1967 to that in 1973?
Your answer should be compact. 1.04. What is the ratio of the Value added (constant 2005 US$) in Agriculture in 1967 to that in 1973?
Keep it short and to the point. 0.82. What is the ratio of the Value added (constant 2005 US$) of Industry in 1967 to that in 1974?
Your answer should be compact. 1.01. What is the ratio of the Value added (constant 2005 US$) of Services in 1967 to that in 1974?
Offer a terse response. 0.93. What is the ratio of the Value added (constant 2005 US$) of Agriculture in 1967 to that in 1974?
Your answer should be very brief. 0.74. What is the ratio of the Value added (constant 2005 US$) in Industry in 1967 to that in 1975?
Provide a short and direct response. 0.86. What is the ratio of the Value added (constant 2005 US$) in Services in 1967 to that in 1975?
Provide a succinct answer. 0.75. What is the ratio of the Value added (constant 2005 US$) in Agriculture in 1967 to that in 1975?
Your answer should be compact. 0.7. What is the ratio of the Value added (constant 2005 US$) in Industry in 1968 to that in 1969?
Your answer should be compact. 1.04. What is the ratio of the Value added (constant 2005 US$) in Services in 1968 to that in 1969?
Your answer should be very brief. 1.05. What is the ratio of the Value added (constant 2005 US$) in Agriculture in 1968 to that in 1969?
Make the answer very short. 0.94. What is the ratio of the Value added (constant 2005 US$) in Industry in 1968 to that in 1970?
Offer a very short reply. 1.07. What is the ratio of the Value added (constant 2005 US$) in Services in 1968 to that in 1970?
Make the answer very short. 1.05. What is the ratio of the Value added (constant 2005 US$) in Agriculture in 1968 to that in 1970?
Your answer should be compact. 0.79. What is the ratio of the Value added (constant 2005 US$) in Industry in 1968 to that in 1971?
Offer a terse response. 1.1. What is the ratio of the Value added (constant 2005 US$) in Services in 1968 to that in 1971?
Provide a short and direct response. 1.04. What is the ratio of the Value added (constant 2005 US$) in Agriculture in 1968 to that in 1971?
Provide a short and direct response. 0.76. What is the ratio of the Value added (constant 2005 US$) of Industry in 1968 to that in 1972?
Provide a short and direct response. 1.17. What is the ratio of the Value added (constant 2005 US$) in Services in 1968 to that in 1972?
Keep it short and to the point. 1.08. What is the ratio of the Value added (constant 2005 US$) of Agriculture in 1968 to that in 1972?
Your answer should be very brief. 0.81. What is the ratio of the Value added (constant 2005 US$) in Industry in 1968 to that in 1973?
Keep it short and to the point. 1.14. What is the ratio of the Value added (constant 2005 US$) of Services in 1968 to that in 1973?
Provide a succinct answer. 1.07. What is the ratio of the Value added (constant 2005 US$) in Agriculture in 1968 to that in 1973?
Offer a terse response. 0.78. What is the ratio of the Value added (constant 2005 US$) in Services in 1968 to that in 1974?
Offer a terse response. 0.95. What is the ratio of the Value added (constant 2005 US$) of Agriculture in 1968 to that in 1974?
Your answer should be compact. 0.7. What is the ratio of the Value added (constant 2005 US$) in Industry in 1968 to that in 1975?
Ensure brevity in your answer.  0.86. What is the ratio of the Value added (constant 2005 US$) in Services in 1968 to that in 1975?
Offer a terse response. 0.77. What is the ratio of the Value added (constant 2005 US$) of Agriculture in 1968 to that in 1975?
Make the answer very short. 0.67. What is the ratio of the Value added (constant 2005 US$) in Industry in 1969 to that in 1970?
Give a very brief answer. 1.02. What is the ratio of the Value added (constant 2005 US$) of Agriculture in 1969 to that in 1970?
Offer a terse response. 0.85. What is the ratio of the Value added (constant 2005 US$) in Industry in 1969 to that in 1971?
Ensure brevity in your answer.  1.05. What is the ratio of the Value added (constant 2005 US$) in Agriculture in 1969 to that in 1971?
Your answer should be compact. 0.82. What is the ratio of the Value added (constant 2005 US$) of Industry in 1969 to that in 1972?
Keep it short and to the point. 1.12. What is the ratio of the Value added (constant 2005 US$) in Services in 1969 to that in 1972?
Offer a terse response. 1.03. What is the ratio of the Value added (constant 2005 US$) in Agriculture in 1969 to that in 1972?
Give a very brief answer. 0.86. What is the ratio of the Value added (constant 2005 US$) of Industry in 1969 to that in 1973?
Your answer should be very brief. 1.09. What is the ratio of the Value added (constant 2005 US$) in Services in 1969 to that in 1973?
Provide a short and direct response. 1.02. What is the ratio of the Value added (constant 2005 US$) in Agriculture in 1969 to that in 1973?
Your answer should be compact. 0.84. What is the ratio of the Value added (constant 2005 US$) in Industry in 1969 to that in 1974?
Give a very brief answer. 0.96. What is the ratio of the Value added (constant 2005 US$) of Services in 1969 to that in 1974?
Make the answer very short. 0.91. What is the ratio of the Value added (constant 2005 US$) in Industry in 1969 to that in 1975?
Keep it short and to the point. 0.83. What is the ratio of the Value added (constant 2005 US$) of Services in 1969 to that in 1975?
Keep it short and to the point. 0.73. What is the ratio of the Value added (constant 2005 US$) in Agriculture in 1969 to that in 1975?
Ensure brevity in your answer.  0.72. What is the ratio of the Value added (constant 2005 US$) of Industry in 1970 to that in 1971?
Make the answer very short. 1.03. What is the ratio of the Value added (constant 2005 US$) in Services in 1970 to that in 1971?
Keep it short and to the point. 0.99. What is the ratio of the Value added (constant 2005 US$) in Agriculture in 1970 to that in 1971?
Your answer should be compact. 0.96. What is the ratio of the Value added (constant 2005 US$) of Industry in 1970 to that in 1972?
Provide a short and direct response. 1.1. What is the ratio of the Value added (constant 2005 US$) of Services in 1970 to that in 1972?
Provide a succinct answer. 1.03. What is the ratio of the Value added (constant 2005 US$) of Agriculture in 1970 to that in 1972?
Provide a short and direct response. 1.02. What is the ratio of the Value added (constant 2005 US$) in Industry in 1970 to that in 1973?
Your response must be concise. 1.07. What is the ratio of the Value added (constant 2005 US$) of Services in 1970 to that in 1973?
Give a very brief answer. 1.02. What is the ratio of the Value added (constant 2005 US$) of Agriculture in 1970 to that in 1973?
Your answer should be compact. 0.98. What is the ratio of the Value added (constant 2005 US$) of Industry in 1970 to that in 1974?
Ensure brevity in your answer.  0.94. What is the ratio of the Value added (constant 2005 US$) of Services in 1970 to that in 1974?
Give a very brief answer. 0.91. What is the ratio of the Value added (constant 2005 US$) in Agriculture in 1970 to that in 1974?
Offer a very short reply. 0.88. What is the ratio of the Value added (constant 2005 US$) of Industry in 1970 to that in 1975?
Ensure brevity in your answer.  0.81. What is the ratio of the Value added (constant 2005 US$) in Services in 1970 to that in 1975?
Give a very brief answer. 0.73. What is the ratio of the Value added (constant 2005 US$) of Agriculture in 1970 to that in 1975?
Offer a very short reply. 0.84. What is the ratio of the Value added (constant 2005 US$) of Industry in 1971 to that in 1972?
Your answer should be very brief. 1.07. What is the ratio of the Value added (constant 2005 US$) of Services in 1971 to that in 1972?
Ensure brevity in your answer.  1.04. What is the ratio of the Value added (constant 2005 US$) in Agriculture in 1971 to that in 1972?
Ensure brevity in your answer.  1.06. What is the ratio of the Value added (constant 2005 US$) of Industry in 1971 to that in 1973?
Offer a terse response. 1.04. What is the ratio of the Value added (constant 2005 US$) in Services in 1971 to that in 1973?
Offer a terse response. 1.03. What is the ratio of the Value added (constant 2005 US$) of Agriculture in 1971 to that in 1973?
Your answer should be compact. 1.02. What is the ratio of the Value added (constant 2005 US$) of Industry in 1971 to that in 1974?
Keep it short and to the point. 0.92. What is the ratio of the Value added (constant 2005 US$) of Services in 1971 to that in 1974?
Make the answer very short. 0.92. What is the ratio of the Value added (constant 2005 US$) in Agriculture in 1971 to that in 1974?
Keep it short and to the point. 0.92. What is the ratio of the Value added (constant 2005 US$) in Industry in 1971 to that in 1975?
Provide a succinct answer. 0.79. What is the ratio of the Value added (constant 2005 US$) in Services in 1971 to that in 1975?
Offer a very short reply. 0.74. What is the ratio of the Value added (constant 2005 US$) of Agriculture in 1971 to that in 1975?
Your answer should be very brief. 0.88. What is the ratio of the Value added (constant 2005 US$) of Industry in 1972 to that in 1973?
Your answer should be compact. 0.97. What is the ratio of the Value added (constant 2005 US$) in Agriculture in 1972 to that in 1973?
Your answer should be very brief. 0.97. What is the ratio of the Value added (constant 2005 US$) of Industry in 1972 to that in 1974?
Provide a succinct answer. 0.86. What is the ratio of the Value added (constant 2005 US$) of Services in 1972 to that in 1974?
Your answer should be compact. 0.88. What is the ratio of the Value added (constant 2005 US$) in Agriculture in 1972 to that in 1974?
Offer a terse response. 0.87. What is the ratio of the Value added (constant 2005 US$) in Industry in 1972 to that in 1975?
Offer a very short reply. 0.74. What is the ratio of the Value added (constant 2005 US$) in Services in 1972 to that in 1975?
Give a very brief answer. 0.71. What is the ratio of the Value added (constant 2005 US$) in Agriculture in 1972 to that in 1975?
Your response must be concise. 0.83. What is the ratio of the Value added (constant 2005 US$) in Industry in 1973 to that in 1974?
Your answer should be very brief. 0.88. What is the ratio of the Value added (constant 2005 US$) in Services in 1973 to that in 1974?
Make the answer very short. 0.89. What is the ratio of the Value added (constant 2005 US$) of Agriculture in 1973 to that in 1974?
Give a very brief answer. 0.9. What is the ratio of the Value added (constant 2005 US$) of Industry in 1973 to that in 1975?
Your answer should be very brief. 0.76. What is the ratio of the Value added (constant 2005 US$) of Services in 1973 to that in 1975?
Your response must be concise. 0.71. What is the ratio of the Value added (constant 2005 US$) of Agriculture in 1973 to that in 1975?
Offer a very short reply. 0.86. What is the ratio of the Value added (constant 2005 US$) in Industry in 1974 to that in 1975?
Your answer should be compact. 0.86. What is the ratio of the Value added (constant 2005 US$) of Services in 1974 to that in 1975?
Your answer should be very brief. 0.8. What is the ratio of the Value added (constant 2005 US$) of Agriculture in 1974 to that in 1975?
Your answer should be very brief. 0.96. What is the difference between the highest and the second highest Value added (constant 2005 US$) of Industry?
Your response must be concise. 1.27e+08. What is the difference between the highest and the second highest Value added (constant 2005 US$) of Services?
Offer a terse response. 5.50e+08. What is the difference between the highest and the second highest Value added (constant 2005 US$) in Agriculture?
Ensure brevity in your answer.  1.58e+08. What is the difference between the highest and the lowest Value added (constant 2005 US$) of Industry?
Keep it short and to the point. 2.49e+08. What is the difference between the highest and the lowest Value added (constant 2005 US$) in Services?
Your answer should be very brief. 8.14e+08. What is the difference between the highest and the lowest Value added (constant 2005 US$) of Agriculture?
Your response must be concise. 1.18e+09. 